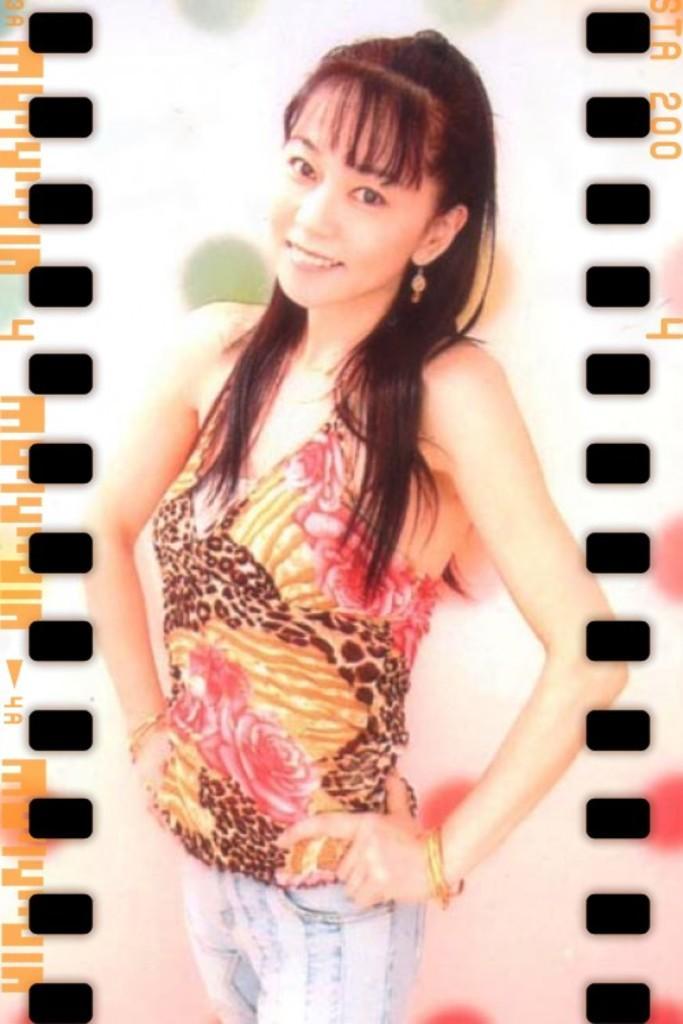Can you describe this image briefly? This is an edited image. Here I can see a woman wearing a t-shirt, jeans, standing, smiling and giving pose for the picture. On the both sides of this image I can see black color marks and some text. 